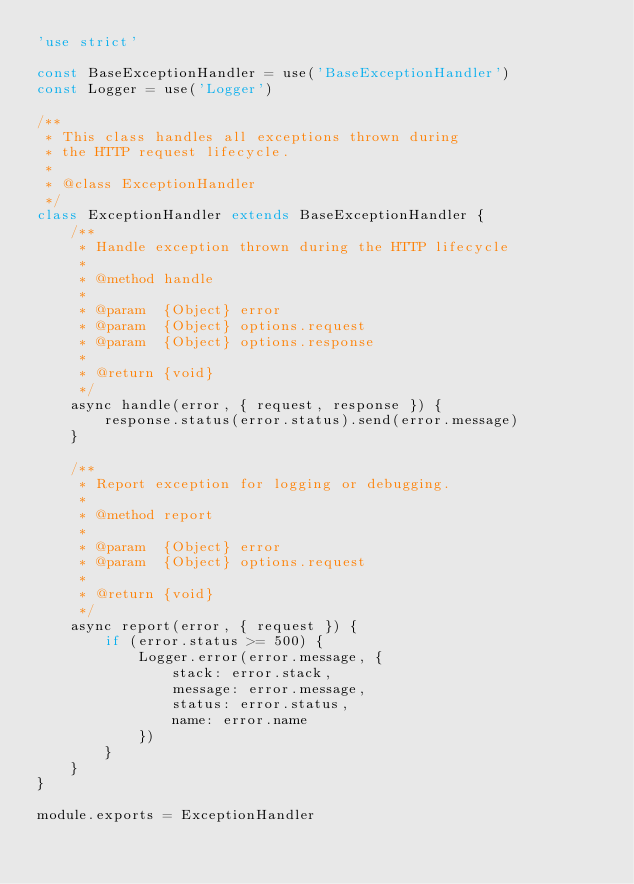Convert code to text. <code><loc_0><loc_0><loc_500><loc_500><_JavaScript_>'use strict'

const BaseExceptionHandler = use('BaseExceptionHandler')
const Logger = use('Logger')

/**
 * This class handles all exceptions thrown during
 * the HTTP request lifecycle.
 *
 * @class ExceptionHandler
 */
class ExceptionHandler extends BaseExceptionHandler {
    /**
     * Handle exception thrown during the HTTP lifecycle
     *
     * @method handle
     *
     * @param  {Object} error
     * @param  {Object} options.request
     * @param  {Object} options.response
     *
     * @return {void}
     */
    async handle(error, { request, response }) {
        response.status(error.status).send(error.message)
    }

    /**
     * Report exception for logging or debugging.
     *
     * @method report
     *
     * @param  {Object} error
     * @param  {Object} options.request
     *
     * @return {void}
     */
    async report(error, { request }) {
        if (error.status >= 500) {
            Logger.error(error.message, {
                stack: error.stack,
                message: error.message,
                status: error.status,
                name: error.name
            })
        }
    }
}

module.exports = ExceptionHandler</code> 